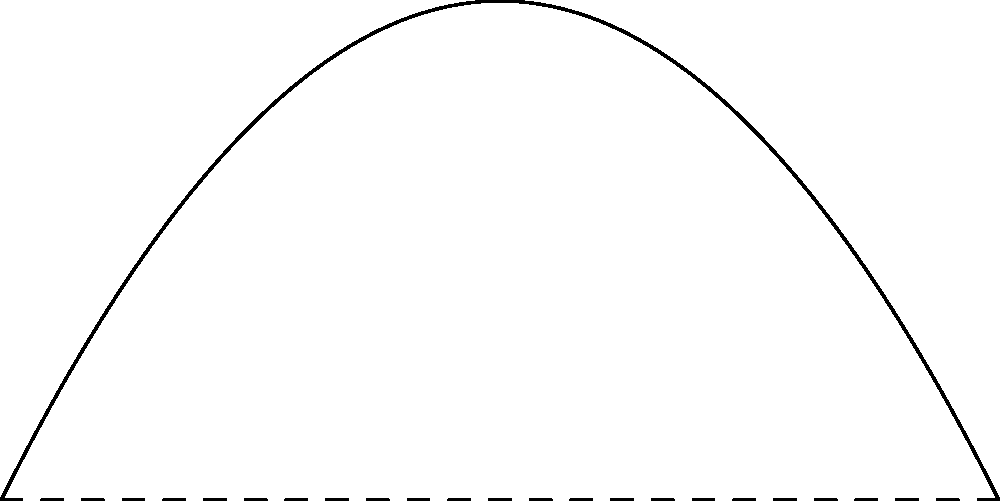As a personal chef preparing a festive salad, you're demonstrating the art of tossing ingredients. The path of a cherry tomato you toss follows a parabolic arc. The tomato leaves your hand at point A(0,0), reaches its highest point at V(5,5), and lands in the salad bowl at point B(10,0). Determine the equation of the parabola that represents the tomato's path. Let's approach this step-by-step:

1) The general form of a parabola is $y = ax^2 + bx + c$.

2) We know three points on this parabola:
   A(0,0), V(5,5), and B(10,0)

3) Since A(0,0) is on the parabola, we know that $c = 0$.

4) The axis of symmetry passes through the vertex V(5,5). For a parabola, the x-coordinate of the vertex is $-b/(2a)$. So:

   $5 = -b/(2a)$
   $b = -10a$

5) Now our equation is $y = ax^2 - 10ax$

6) We can use point V(5,5) to find $a$:
   $5 = a(5^2) - 10a(5)$
   $5 = 25a - 50a$
   $5 = -25a$
   $a = -1/5 = -0.2$

7) Therefore, the equation is:
   $y = -0.2x^2 + 2x$

We can verify this with point B(10,0):
$0 = -0.2(10^2) + 2(10)$
$0 = -20 + 20$
$0 = 0$ (which checks out)
Answer: $y = -0.2x^2 + 2x$ 